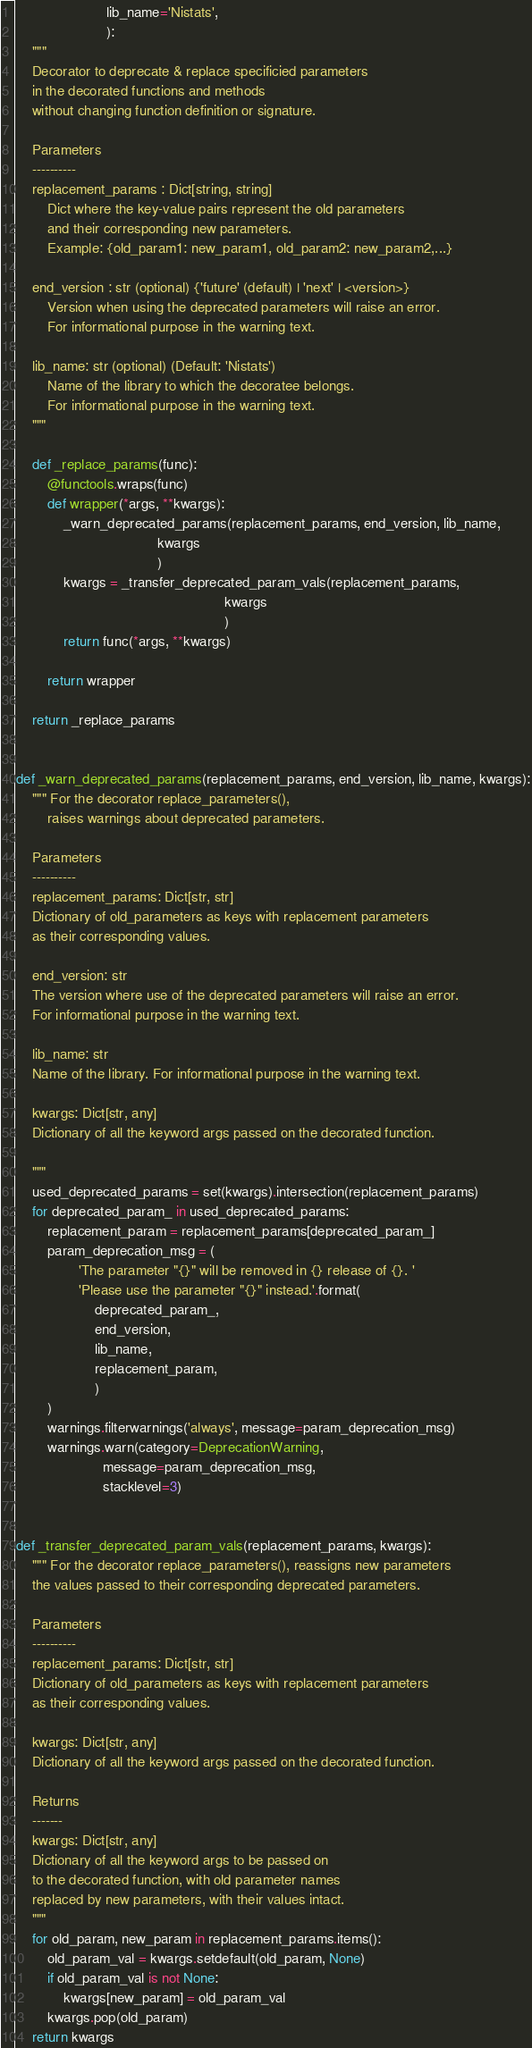<code> <loc_0><loc_0><loc_500><loc_500><_Python_>                       lib_name='Nistats',
                       ):
    """
    Decorator to deprecate & replace specificied parameters
    in the decorated functions and methods
    without changing function definition or signature.

    Parameters
    ----------
    replacement_params : Dict[string, string]
        Dict where the key-value pairs represent the old parameters
        and their corresponding new parameters.
        Example: {old_param1: new_param1, old_param2: new_param2,...}

    end_version : str (optional) {'future' (default) | 'next' | <version>}
        Version when using the deprecated parameters will raise an error.
        For informational purpose in the warning text.

    lib_name: str (optional) (Default: 'Nistats')
        Name of the library to which the decoratee belongs.
        For informational purpose in the warning text.
    """

    def _replace_params(func):
        @functools.wraps(func)
        def wrapper(*args, **kwargs):
            _warn_deprecated_params(replacement_params, end_version, lib_name,
                                    kwargs
                                    )
            kwargs = _transfer_deprecated_param_vals(replacement_params,
                                                     kwargs
                                                     )
            return func(*args, **kwargs)

        return wrapper

    return _replace_params


def _warn_deprecated_params(replacement_params, end_version, lib_name, kwargs):
    """ For the decorator replace_parameters(),
        raises warnings about deprecated parameters.

    Parameters
    ----------
    replacement_params: Dict[str, str]
    Dictionary of old_parameters as keys with replacement parameters
    as their corresponding values.

    end_version: str
    The version where use of the deprecated parameters will raise an error.
    For informational purpose in the warning text.

    lib_name: str
    Name of the library. For informational purpose in the warning text.

    kwargs: Dict[str, any]
    Dictionary of all the keyword args passed on the decorated function.

    """
    used_deprecated_params = set(kwargs).intersection(replacement_params)
    for deprecated_param_ in used_deprecated_params:
        replacement_param = replacement_params[deprecated_param_]
        param_deprecation_msg = (
                'The parameter "{}" will be removed in {} release of {}. '
                'Please use the parameter "{}" instead.'.format(
                    deprecated_param_,
                    end_version,
                    lib_name,
                    replacement_param,
                    )
        )
        warnings.filterwarnings('always', message=param_deprecation_msg)
        warnings.warn(category=DeprecationWarning,
                      message=param_deprecation_msg,
                      stacklevel=3)


def _transfer_deprecated_param_vals(replacement_params, kwargs):
    """ For the decorator replace_parameters(), reassigns new parameters
    the values passed to their corresponding deprecated parameters.

    Parameters
    ----------
    replacement_params: Dict[str, str]
    Dictionary of old_parameters as keys with replacement parameters
    as their corresponding values.

    kwargs: Dict[str, any]
    Dictionary of all the keyword args passed on the decorated function.

    Returns
    -------
    kwargs: Dict[str, any]
    Dictionary of all the keyword args to be passed on
    to the decorated function, with old parameter names
    replaced by new parameters, with their values intact.
    """
    for old_param, new_param in replacement_params.items():
        old_param_val = kwargs.setdefault(old_param, None)
        if old_param_val is not None:
            kwargs[new_param] = old_param_val
        kwargs.pop(old_param)
    return kwargs
</code> 